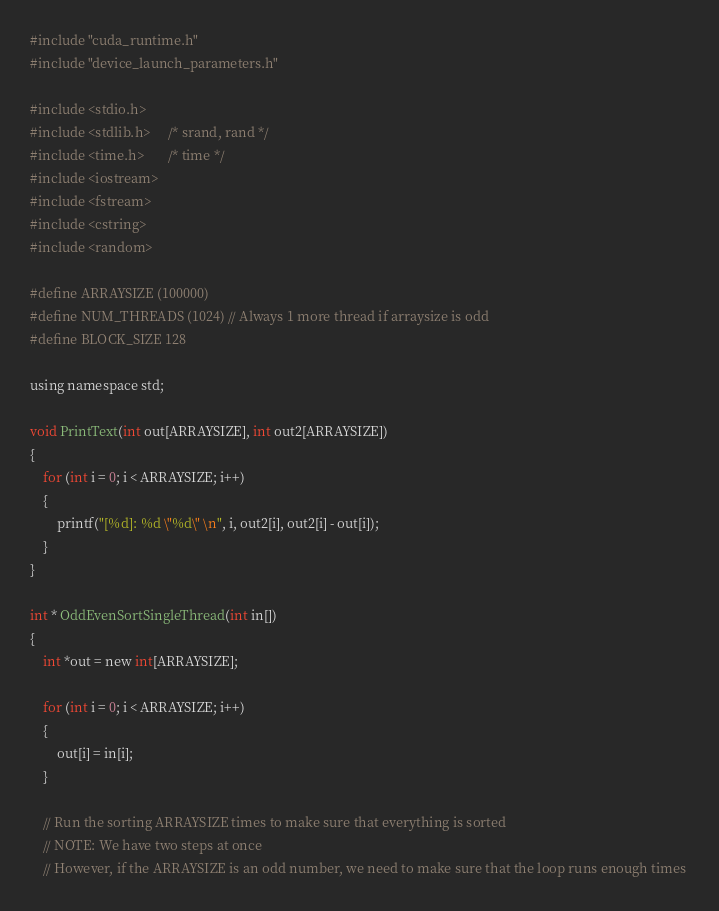Convert code to text. <code><loc_0><loc_0><loc_500><loc_500><_Cuda_>#include "cuda_runtime.h"
#include "device_launch_parameters.h"

#include <stdio.h>
#include <stdlib.h>     /* srand, rand */
#include <time.h>       /* time */
#include <iostream>
#include <fstream>
#include <cstring>
#include <random>

#define ARRAYSIZE (100000)
#define NUM_THREADS (1024) // Always 1 more thread if arraysize is odd
#define BLOCK_SIZE 128

using namespace std;

void PrintText(int out[ARRAYSIZE], int out2[ARRAYSIZE])
{
	for (int i = 0; i < ARRAYSIZE; i++)
	{
		printf("[%d]: %d \"%d\" \n", i, out2[i], out2[i] - out[i]);
	}
}

int * OddEvenSortSingleThread(int in[])
{
	int *out = new int[ARRAYSIZE];

	for (int i = 0; i < ARRAYSIZE; i++)
	{
		out[i] = in[i];
	}

	// Run the sorting ARRAYSIZE times to make sure that everything is sorted
	// NOTE: We have two steps at once
	// However, if the ARRAYSIZE is an odd number, we need to make sure that the loop runs enough times </code> 